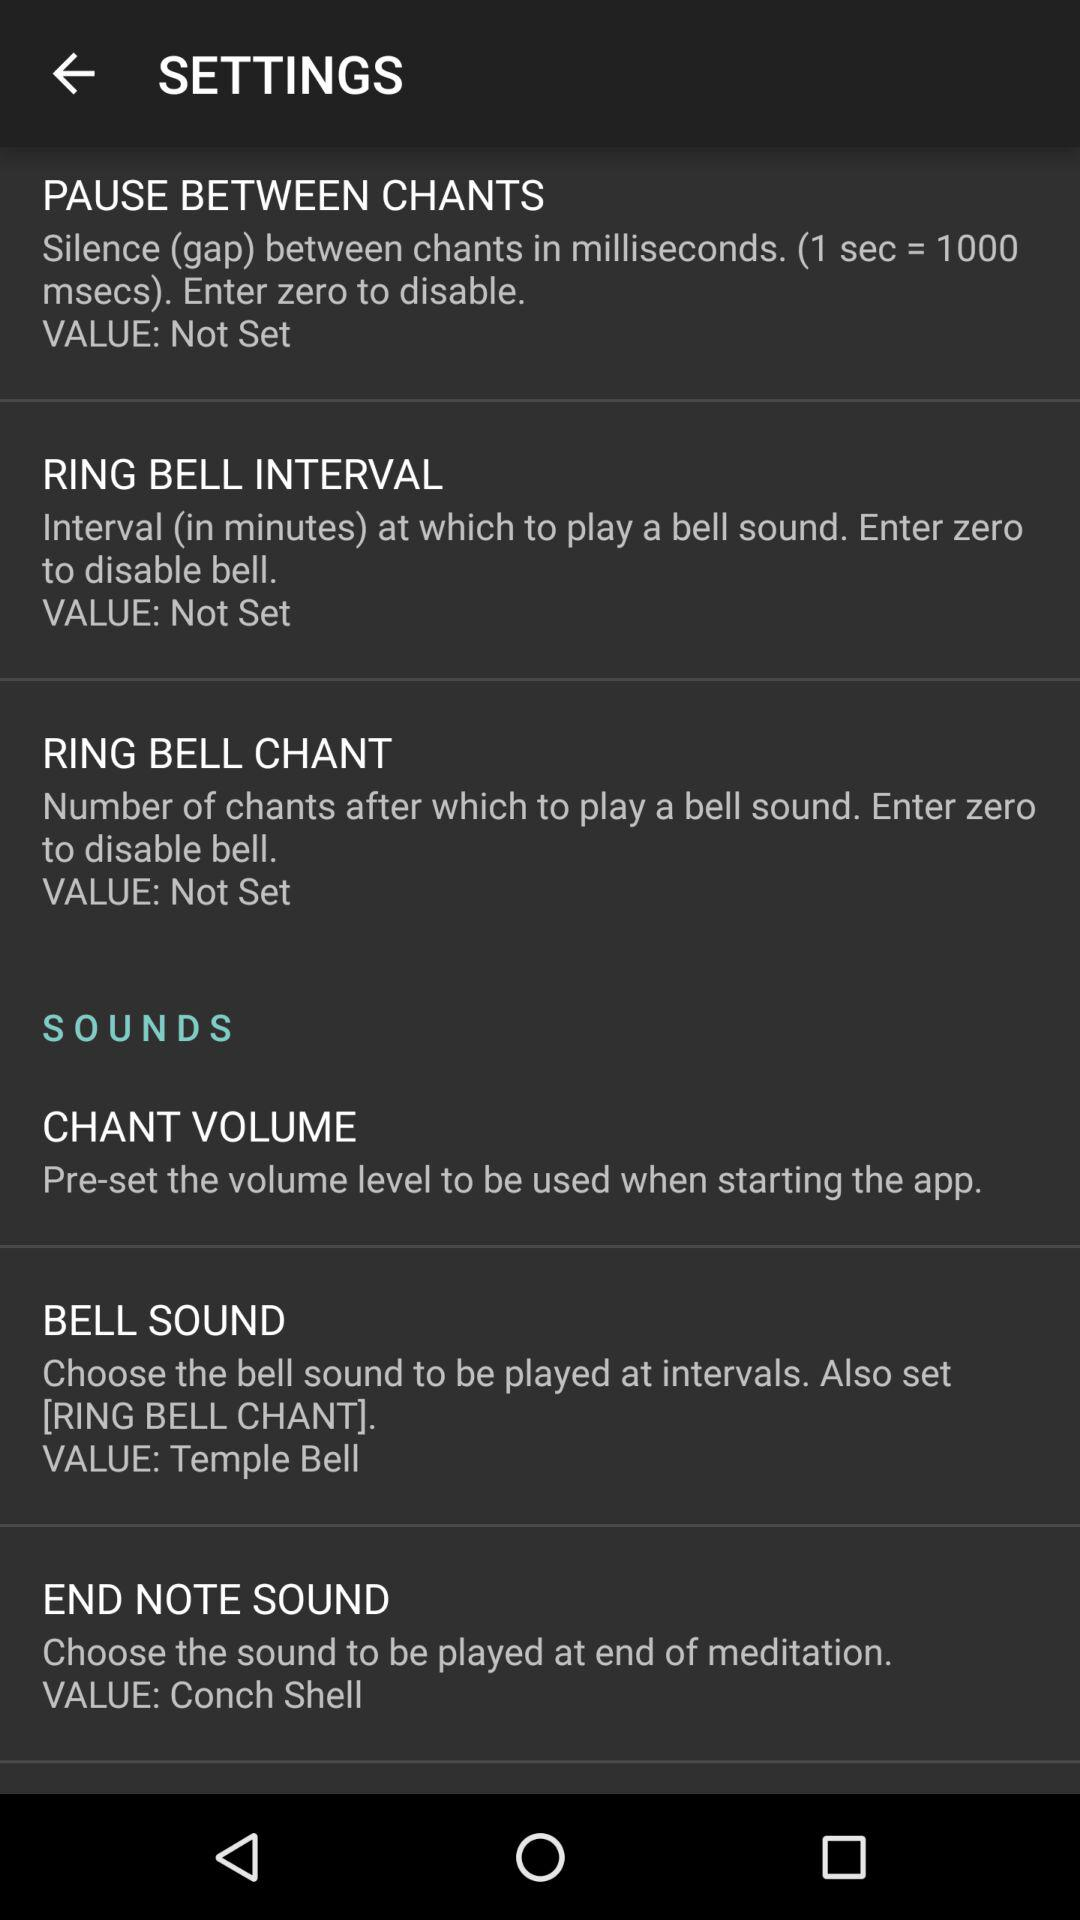Which value can be entered to disable the bell for "Ring Bell Chants"? You can enter zero to disable the bell for "Ring Bell Chants". 